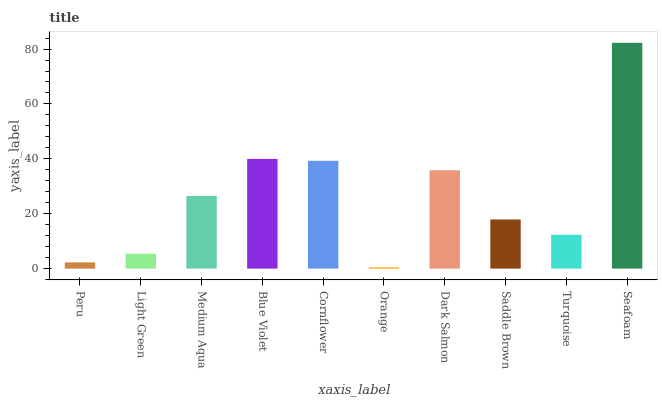Is Light Green the minimum?
Answer yes or no. No. Is Light Green the maximum?
Answer yes or no. No. Is Light Green greater than Peru?
Answer yes or no. Yes. Is Peru less than Light Green?
Answer yes or no. Yes. Is Peru greater than Light Green?
Answer yes or no. No. Is Light Green less than Peru?
Answer yes or no. No. Is Medium Aqua the high median?
Answer yes or no. Yes. Is Saddle Brown the low median?
Answer yes or no. Yes. Is Turquoise the high median?
Answer yes or no. No. Is Dark Salmon the low median?
Answer yes or no. No. 